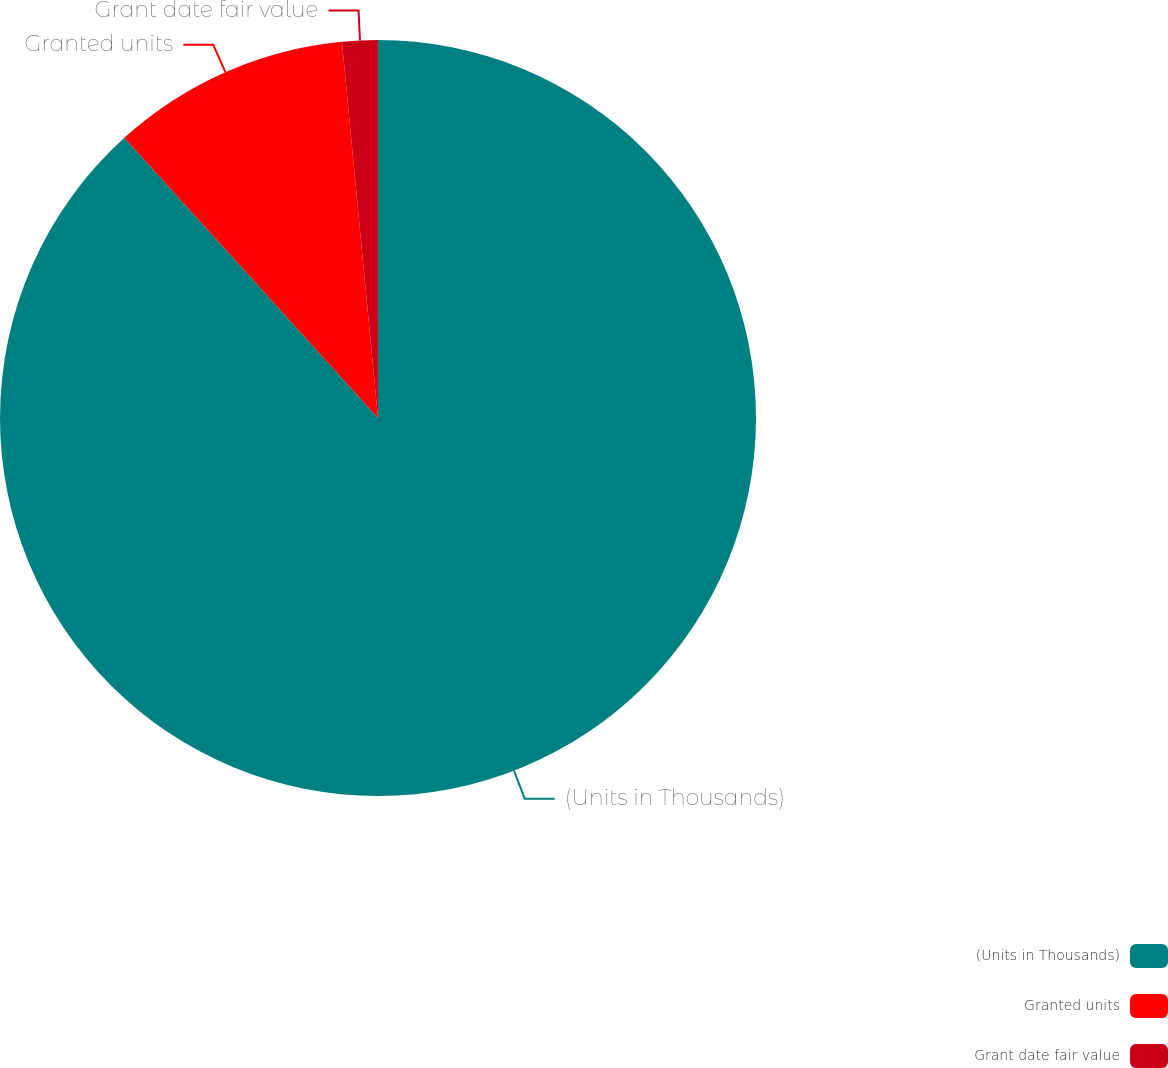<chart> <loc_0><loc_0><loc_500><loc_500><pie_chart><fcel>(Units in Thousands)<fcel>Granted units<fcel>Grant date fair value<nl><fcel>88.29%<fcel>10.19%<fcel>1.52%<nl></chart> 